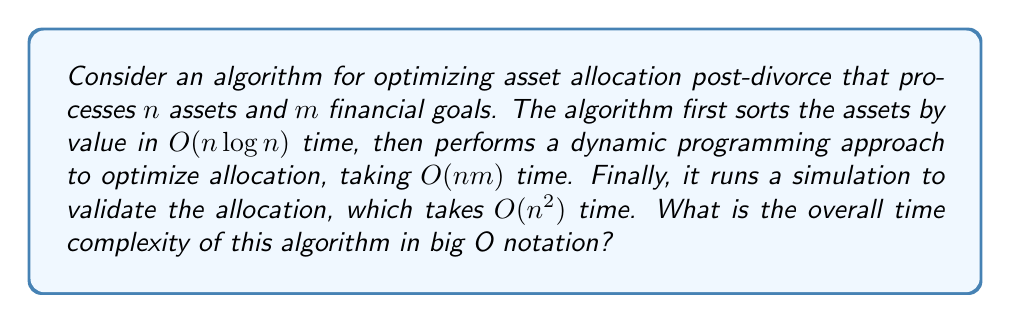Can you answer this question? To determine the overall time complexity, we need to analyze each step of the algorithm and combine them:

1. Sorting assets: $O(n \log n)$
2. Dynamic programming optimization: $O(nm)$
3. Validation simulation: $O(n^2)$

To combine these, we need to consider the dominant term. Let's compare them:

a) $O(n \log n)$ vs $O(nm)$:
   - If $m > \log n$, then $O(nm)$ dominates
   - If $m \leq \log n$, then $O(n \log n)$ dominates

b) $O(n^2)$ vs $O(nm)$ and $O(n \log n)$:
   - $O(n^2)$ will always dominate $O(n \log n)$ for sufficiently large $n$
   - $O(n^2)$ will dominate $O(nm)$ when $n > m$

Therefore, the overall time complexity will be the maximum of $O(n^2)$ and $O(nm)$.

We can express this as: $O(\max(n^2, nm))$

This can be simplified to:
- If $n > m$: $O(n^2)$
- If $n \leq m$: $O(nm)$

Since we don't know the relationship between $n$ and $m$, we keep the complexity as $O(\max(n^2, nm))$.
Answer: $O(\max(n^2, nm))$ 